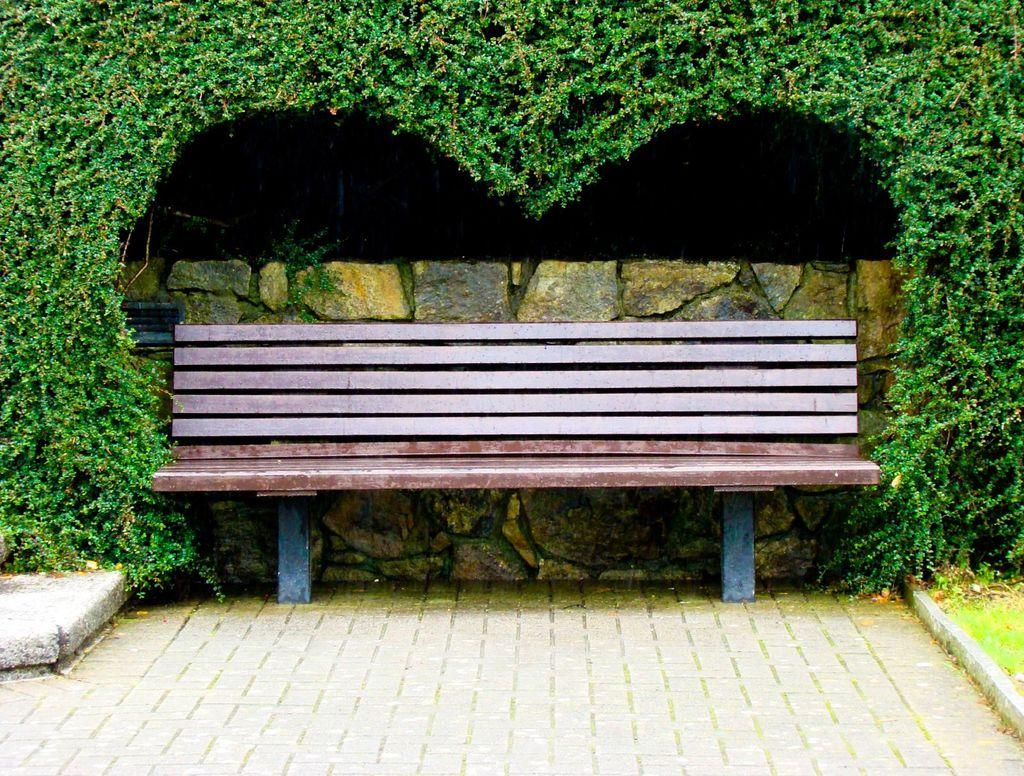What type of seating is present in the image? There is a bench in the image. Where is the bench located? The bench is on the floor. What can be seen in the background of the image? There is grass and a wall visible in the background of the image. What books are being read at the event depicted in the image? There is no event or books present in the image; it features a bench on the floor with a grassy and walled background. 